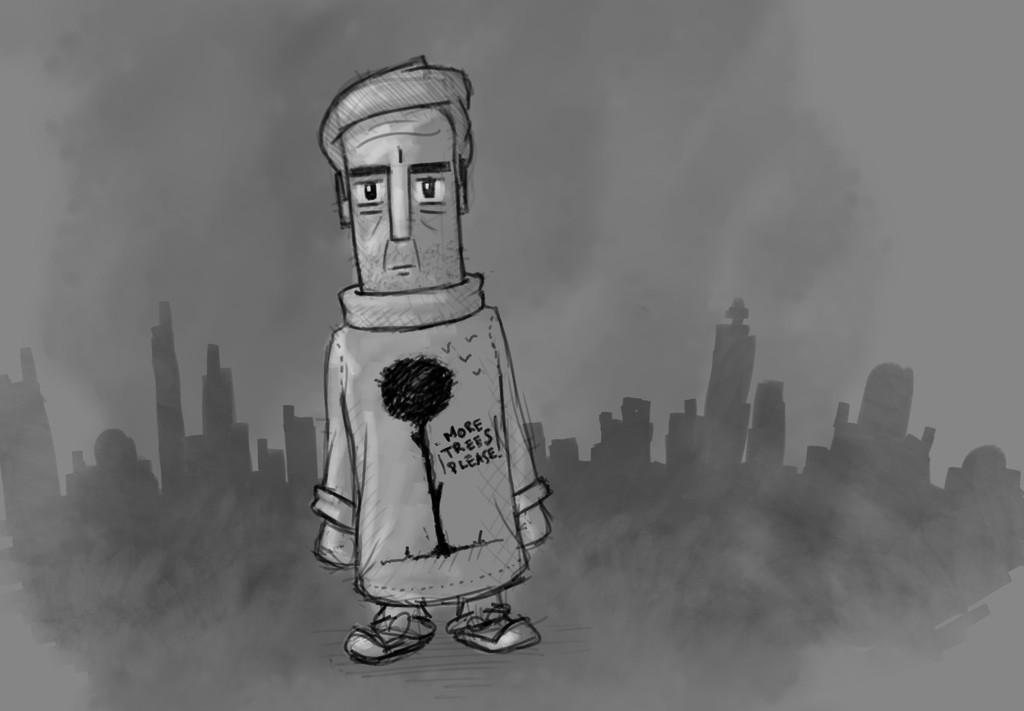What is the main subject of the animated picture in the image? There is an animated picture of a person standing in the image. What can be observed about the person's attire? The person is wearing clothes. What type of environment is depicted in the image? There are many buildings in the image, suggesting an urban setting. What is the source of the smoke visible in the image? The source of the smoke is not specified in the image. What is visible in the background of the image? The sky is visible in the image. How many apples are being held by the person in the image? There are no apples visible in the image; the person is not holding any. What type of hall can be seen in the background of the image? There is no hall present in the image; the background consists of buildings and the sky. 